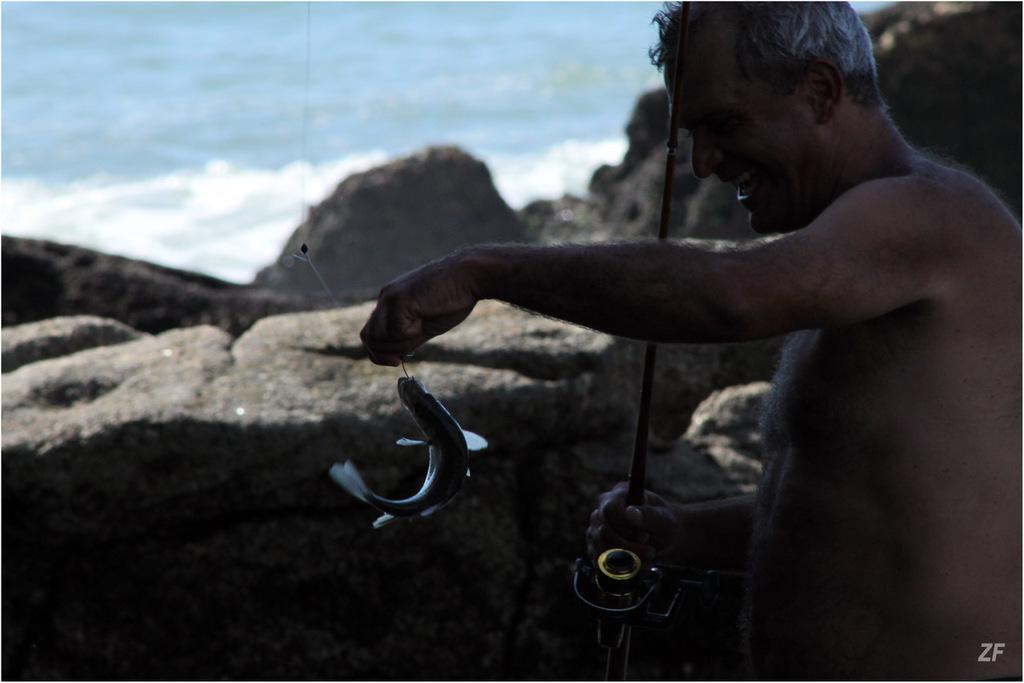Who or what is the main subject in the image? There is a person in the image. What is the person holding in the image? The person is holding a stick. What else can be seen in the image besides the person? There is a fish in the image. What is the background of the image composed of? There are rocks and water visible in the background of the image. What letter is the person trying to write in the water with the stick? There is no letter being written in the water with the stick in the image. 